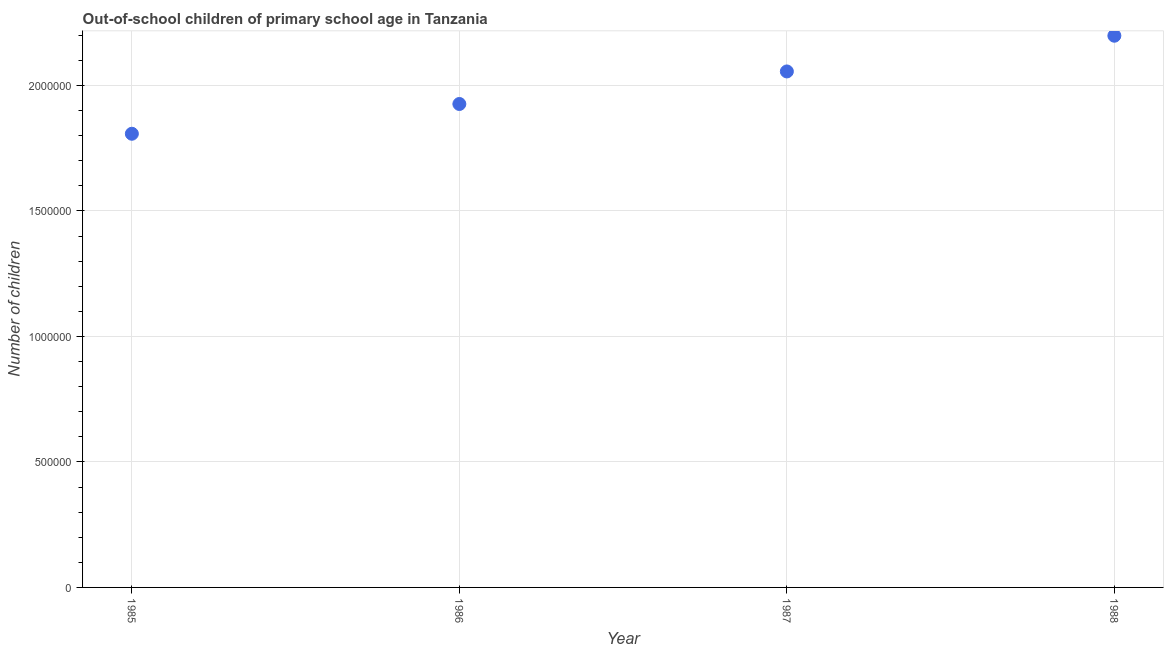What is the number of out-of-school children in 1987?
Offer a terse response. 2.06e+06. Across all years, what is the maximum number of out-of-school children?
Provide a succinct answer. 2.20e+06. Across all years, what is the minimum number of out-of-school children?
Make the answer very short. 1.81e+06. What is the sum of the number of out-of-school children?
Offer a very short reply. 7.99e+06. What is the difference between the number of out-of-school children in 1986 and 1988?
Provide a short and direct response. -2.72e+05. What is the average number of out-of-school children per year?
Provide a short and direct response. 2.00e+06. What is the median number of out-of-school children?
Your answer should be compact. 1.99e+06. What is the ratio of the number of out-of-school children in 1985 to that in 1988?
Offer a terse response. 0.82. What is the difference between the highest and the second highest number of out-of-school children?
Your answer should be compact. 1.42e+05. Is the sum of the number of out-of-school children in 1986 and 1988 greater than the maximum number of out-of-school children across all years?
Your answer should be very brief. Yes. What is the difference between the highest and the lowest number of out-of-school children?
Give a very brief answer. 3.91e+05. In how many years, is the number of out-of-school children greater than the average number of out-of-school children taken over all years?
Offer a very short reply. 2. How many dotlines are there?
Your answer should be compact. 1. How many years are there in the graph?
Your answer should be compact. 4. Are the values on the major ticks of Y-axis written in scientific E-notation?
Ensure brevity in your answer.  No. Does the graph contain any zero values?
Make the answer very short. No. What is the title of the graph?
Ensure brevity in your answer.  Out-of-school children of primary school age in Tanzania. What is the label or title of the Y-axis?
Keep it short and to the point. Number of children. What is the Number of children in 1985?
Offer a very short reply. 1.81e+06. What is the Number of children in 1986?
Provide a short and direct response. 1.93e+06. What is the Number of children in 1987?
Offer a very short reply. 2.06e+06. What is the Number of children in 1988?
Ensure brevity in your answer.  2.20e+06. What is the difference between the Number of children in 1985 and 1986?
Make the answer very short. -1.19e+05. What is the difference between the Number of children in 1985 and 1987?
Offer a terse response. -2.48e+05. What is the difference between the Number of children in 1985 and 1988?
Offer a terse response. -3.91e+05. What is the difference between the Number of children in 1986 and 1987?
Offer a terse response. -1.30e+05. What is the difference between the Number of children in 1986 and 1988?
Keep it short and to the point. -2.72e+05. What is the difference between the Number of children in 1987 and 1988?
Offer a terse response. -1.42e+05. What is the ratio of the Number of children in 1985 to that in 1986?
Keep it short and to the point. 0.94. What is the ratio of the Number of children in 1985 to that in 1987?
Provide a short and direct response. 0.88. What is the ratio of the Number of children in 1985 to that in 1988?
Your answer should be very brief. 0.82. What is the ratio of the Number of children in 1986 to that in 1987?
Your answer should be very brief. 0.94. What is the ratio of the Number of children in 1986 to that in 1988?
Offer a very short reply. 0.88. What is the ratio of the Number of children in 1987 to that in 1988?
Your answer should be compact. 0.94. 